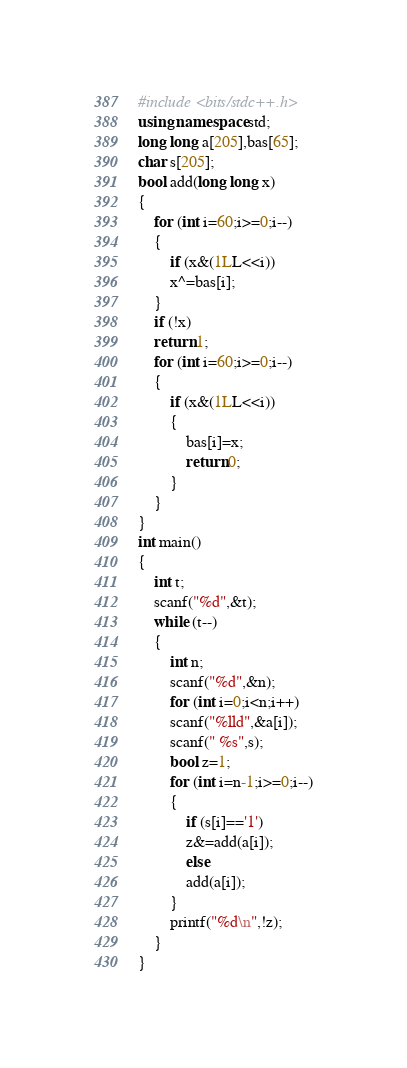Convert code to text. <code><loc_0><loc_0><loc_500><loc_500><_C++_>#include <bits/stdc++.h>
using namespace std;
long long a[205],bas[65];
char s[205];
bool add(long long x)
{
	for (int i=60;i>=0;i--)
	{
		if (x&(1LL<<i))
		x^=bas[i];
	}
	if (!x)
	return 1;
	for (int i=60;i>=0;i--)
	{
		if (x&(1LL<<i))
		{
			bas[i]=x;
			return 0;
		}
	}
}
int main()
{
	int t;
	scanf("%d",&t);
	while (t--)
	{
		int n;
		scanf("%d",&n);
		for (int i=0;i<n;i++)
		scanf("%lld",&a[i]);
		scanf(" %s",s);
		bool z=1;
		for (int i=n-1;i>=0;i--)
		{
			if (s[i]=='1')
			z&=add(a[i]);
			else
			add(a[i]);
		}
		printf("%d\n",!z);
	}
}</code> 